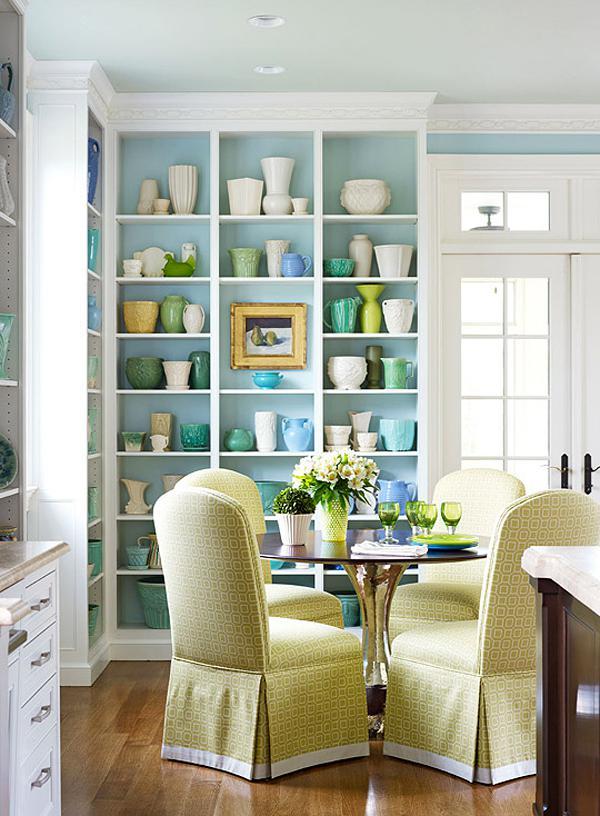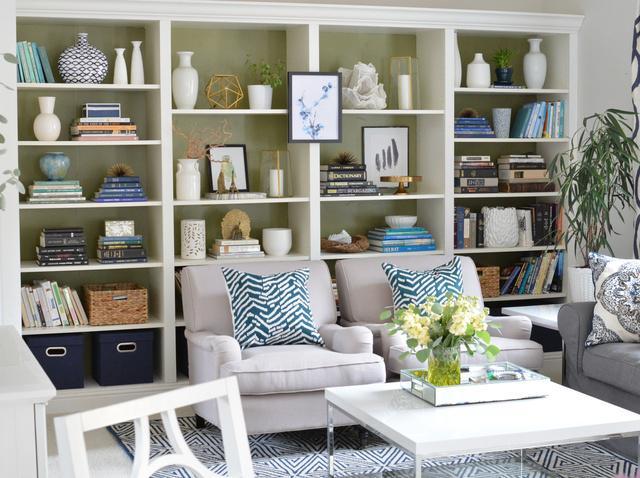The first image is the image on the left, the second image is the image on the right. Evaluate the accuracy of this statement regarding the images: "A plant is sitting near the furniture in the room in the image on the right.". Is it true? Answer yes or no. Yes. The first image is the image on the left, the second image is the image on the right. For the images shown, is this caption "In one image, white shelving units, in a room with a sofa, chair and coffee table, have four levels of upper shelves and solid panel doors below." true? Answer yes or no. No. 